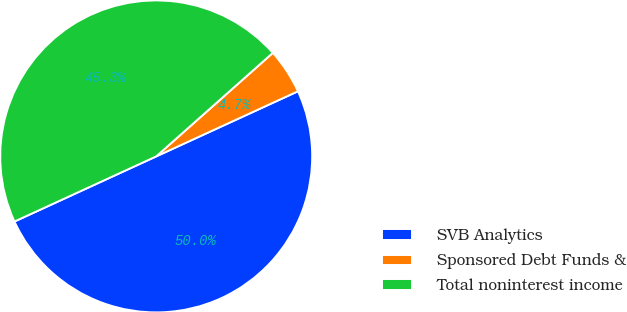<chart> <loc_0><loc_0><loc_500><loc_500><pie_chart><fcel>SVB Analytics<fcel>Sponsored Debt Funds &<fcel>Total noninterest income<nl><fcel>50.0%<fcel>4.7%<fcel>45.3%<nl></chart> 